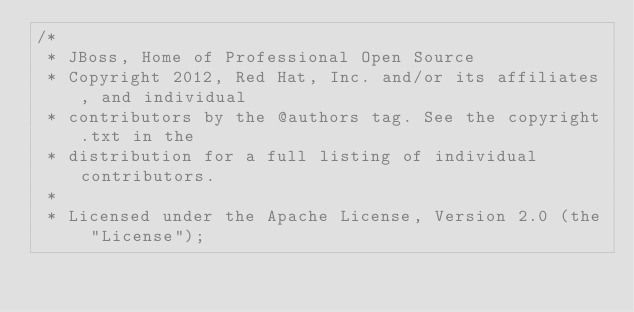<code> <loc_0><loc_0><loc_500><loc_500><_Java_>/*
 * JBoss, Home of Professional Open Source
 * Copyright 2012, Red Hat, Inc. and/or its affiliates, and individual
 * contributors by the @authors tag. See the copyright.txt in the 
 * distribution for a full listing of individual contributors.
 *
 * Licensed under the Apache License, Version 2.0 (the "License");</code> 